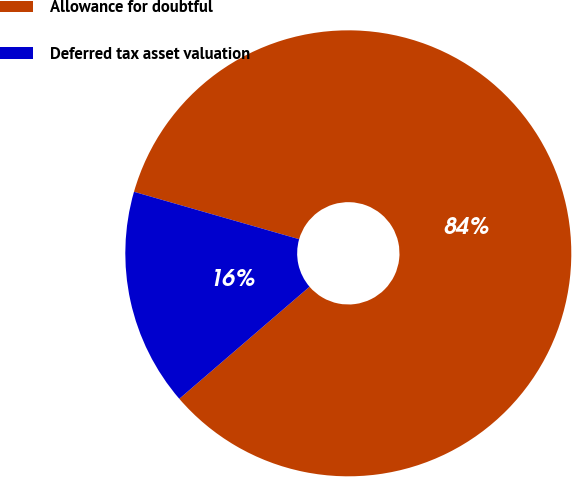<chart> <loc_0><loc_0><loc_500><loc_500><pie_chart><fcel>Allowance for doubtful<fcel>Deferred tax asset valuation<nl><fcel>84.24%<fcel>15.76%<nl></chart> 